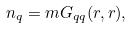Convert formula to latex. <formula><loc_0><loc_0><loc_500><loc_500>n _ { q } = m G _ { q q } ( { r } , { r } ) ,</formula> 